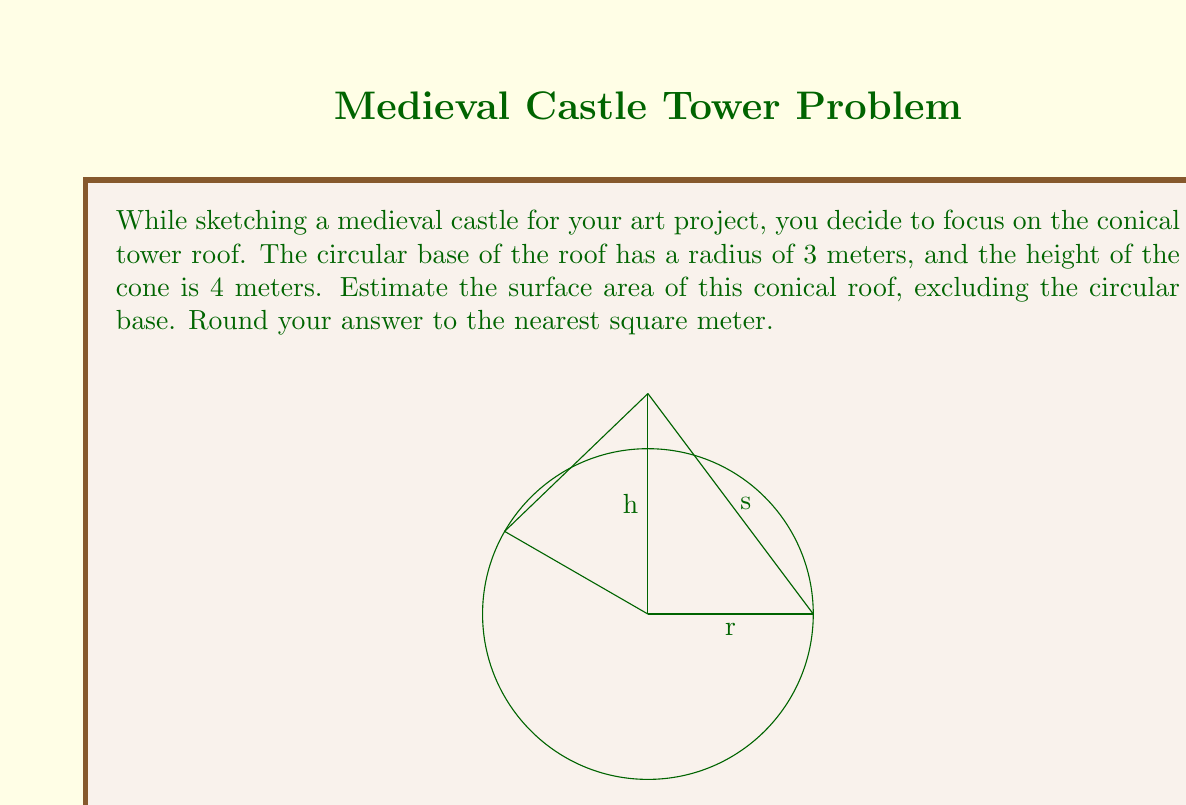Can you answer this question? To estimate the surface area of the conical roof, we'll use the formula for the lateral surface area of a cone:

$$A = \pi rs$$

Where:
$A$ is the lateral surface area
$r$ is the radius of the base
$s$ is the slant height of the cone

We're given:
$r = 3$ meters
$h = 4$ meters (height of the cone)

Step 1: Calculate the slant height $s$ using the Pythagorean theorem:
$$s^2 = r^2 + h^2$$
$$s^2 = 3^2 + 4^2 = 9 + 16 = 25$$
$$s = \sqrt{25} = 5$ meters$$

Step 2: Apply the formula for the lateral surface area:
$$A = \pi rs$$
$$A = \pi \cdot 3 \cdot 5$$
$$A = 15\pi \approx 47.12$ square meters$$

Step 3: Round to the nearest square meter:
$47.12$ rounds to $47$ square meters.
Answer: 47 square meters 